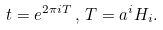Convert formula to latex. <formula><loc_0><loc_0><loc_500><loc_500>t = e ^ { 2 \pi i T } \, , \, T = a ^ { i } H _ { i } .</formula> 